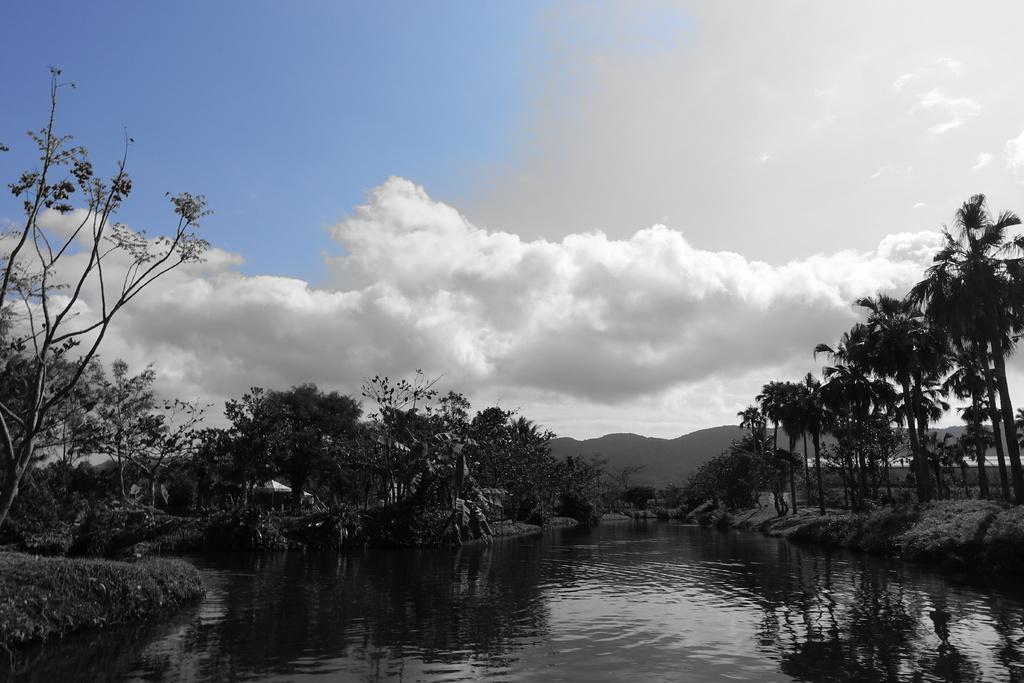Please provide a concise description of this image. In this image I can see water. There are hills, trees, there is grass and in the background there is sky. 